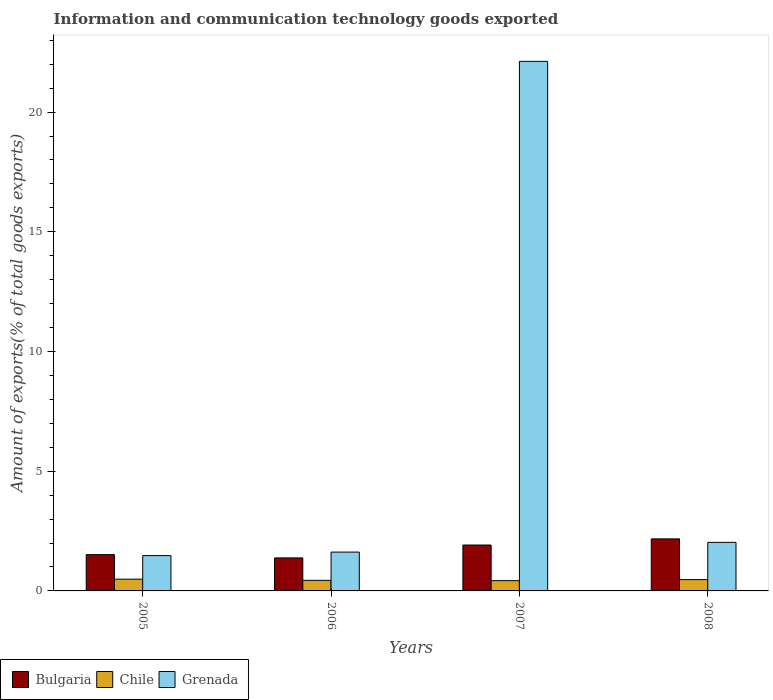How many different coloured bars are there?
Make the answer very short. 3. How many groups of bars are there?
Provide a succinct answer. 4. Are the number of bars per tick equal to the number of legend labels?
Your answer should be very brief. Yes. Are the number of bars on each tick of the X-axis equal?
Ensure brevity in your answer.  Yes. How many bars are there on the 1st tick from the right?
Ensure brevity in your answer.  3. What is the amount of goods exported in Chile in 2007?
Keep it short and to the point. 0.43. Across all years, what is the maximum amount of goods exported in Chile?
Provide a short and direct response. 0.49. Across all years, what is the minimum amount of goods exported in Chile?
Offer a very short reply. 0.43. What is the total amount of goods exported in Chile in the graph?
Provide a short and direct response. 1.84. What is the difference between the amount of goods exported in Chile in 2006 and that in 2007?
Keep it short and to the point. 0.01. What is the difference between the amount of goods exported in Chile in 2008 and the amount of goods exported in Grenada in 2005?
Keep it short and to the point. -1. What is the average amount of goods exported in Grenada per year?
Your response must be concise. 6.81. In the year 2006, what is the difference between the amount of goods exported in Grenada and amount of goods exported in Chile?
Make the answer very short. 1.18. In how many years, is the amount of goods exported in Chile greater than 2 %?
Offer a very short reply. 0. What is the ratio of the amount of goods exported in Bulgaria in 2006 to that in 2008?
Your response must be concise. 0.63. Is the amount of goods exported in Chile in 2005 less than that in 2007?
Your answer should be very brief. No. Is the difference between the amount of goods exported in Grenada in 2005 and 2007 greater than the difference between the amount of goods exported in Chile in 2005 and 2007?
Offer a very short reply. No. What is the difference between the highest and the second highest amount of goods exported in Grenada?
Offer a terse response. 20.09. What is the difference between the highest and the lowest amount of goods exported in Grenada?
Ensure brevity in your answer.  20.65. What does the 3rd bar from the left in 2007 represents?
Give a very brief answer. Grenada. Is it the case that in every year, the sum of the amount of goods exported in Grenada and amount of goods exported in Chile is greater than the amount of goods exported in Bulgaria?
Give a very brief answer. Yes. How many bars are there?
Your answer should be very brief. 12. How many years are there in the graph?
Ensure brevity in your answer.  4. What is the difference between two consecutive major ticks on the Y-axis?
Your answer should be very brief. 5. Does the graph contain any zero values?
Provide a succinct answer. No. Does the graph contain grids?
Keep it short and to the point. No. What is the title of the graph?
Your answer should be very brief. Information and communication technology goods exported. What is the label or title of the X-axis?
Make the answer very short. Years. What is the label or title of the Y-axis?
Provide a succinct answer. Amount of exports(% of total goods exports). What is the Amount of exports(% of total goods exports) in Bulgaria in 2005?
Your answer should be compact. 1.52. What is the Amount of exports(% of total goods exports) of Chile in 2005?
Offer a very short reply. 0.49. What is the Amount of exports(% of total goods exports) in Grenada in 2005?
Make the answer very short. 1.48. What is the Amount of exports(% of total goods exports) in Bulgaria in 2006?
Your answer should be very brief. 1.38. What is the Amount of exports(% of total goods exports) in Chile in 2006?
Your answer should be compact. 0.44. What is the Amount of exports(% of total goods exports) of Grenada in 2006?
Provide a succinct answer. 1.62. What is the Amount of exports(% of total goods exports) of Bulgaria in 2007?
Offer a very short reply. 1.92. What is the Amount of exports(% of total goods exports) in Chile in 2007?
Provide a succinct answer. 0.43. What is the Amount of exports(% of total goods exports) in Grenada in 2007?
Your answer should be very brief. 22.12. What is the Amount of exports(% of total goods exports) of Bulgaria in 2008?
Ensure brevity in your answer.  2.17. What is the Amount of exports(% of total goods exports) of Chile in 2008?
Your answer should be very brief. 0.47. What is the Amount of exports(% of total goods exports) in Grenada in 2008?
Ensure brevity in your answer.  2.03. Across all years, what is the maximum Amount of exports(% of total goods exports) in Bulgaria?
Offer a terse response. 2.17. Across all years, what is the maximum Amount of exports(% of total goods exports) of Chile?
Offer a very short reply. 0.49. Across all years, what is the maximum Amount of exports(% of total goods exports) of Grenada?
Give a very brief answer. 22.12. Across all years, what is the minimum Amount of exports(% of total goods exports) of Bulgaria?
Your response must be concise. 1.38. Across all years, what is the minimum Amount of exports(% of total goods exports) of Chile?
Your answer should be compact. 0.43. Across all years, what is the minimum Amount of exports(% of total goods exports) of Grenada?
Your response must be concise. 1.48. What is the total Amount of exports(% of total goods exports) of Bulgaria in the graph?
Offer a terse response. 6.99. What is the total Amount of exports(% of total goods exports) of Chile in the graph?
Provide a succinct answer. 1.84. What is the total Amount of exports(% of total goods exports) of Grenada in the graph?
Offer a terse response. 27.25. What is the difference between the Amount of exports(% of total goods exports) of Bulgaria in 2005 and that in 2006?
Provide a succinct answer. 0.14. What is the difference between the Amount of exports(% of total goods exports) in Chile in 2005 and that in 2006?
Make the answer very short. 0.05. What is the difference between the Amount of exports(% of total goods exports) in Grenada in 2005 and that in 2006?
Give a very brief answer. -0.15. What is the difference between the Amount of exports(% of total goods exports) of Bulgaria in 2005 and that in 2007?
Give a very brief answer. -0.4. What is the difference between the Amount of exports(% of total goods exports) of Chile in 2005 and that in 2007?
Your response must be concise. 0.06. What is the difference between the Amount of exports(% of total goods exports) of Grenada in 2005 and that in 2007?
Your response must be concise. -20.65. What is the difference between the Amount of exports(% of total goods exports) in Bulgaria in 2005 and that in 2008?
Your answer should be compact. -0.66. What is the difference between the Amount of exports(% of total goods exports) in Chile in 2005 and that in 2008?
Make the answer very short. 0.02. What is the difference between the Amount of exports(% of total goods exports) of Grenada in 2005 and that in 2008?
Keep it short and to the point. -0.55. What is the difference between the Amount of exports(% of total goods exports) of Bulgaria in 2006 and that in 2007?
Give a very brief answer. -0.54. What is the difference between the Amount of exports(% of total goods exports) of Chile in 2006 and that in 2007?
Keep it short and to the point. 0.01. What is the difference between the Amount of exports(% of total goods exports) in Grenada in 2006 and that in 2007?
Give a very brief answer. -20.5. What is the difference between the Amount of exports(% of total goods exports) of Bulgaria in 2006 and that in 2008?
Make the answer very short. -0.8. What is the difference between the Amount of exports(% of total goods exports) in Chile in 2006 and that in 2008?
Provide a short and direct response. -0.03. What is the difference between the Amount of exports(% of total goods exports) in Grenada in 2006 and that in 2008?
Offer a terse response. -0.41. What is the difference between the Amount of exports(% of total goods exports) in Bulgaria in 2007 and that in 2008?
Offer a very short reply. -0.26. What is the difference between the Amount of exports(% of total goods exports) in Chile in 2007 and that in 2008?
Your answer should be compact. -0.05. What is the difference between the Amount of exports(% of total goods exports) of Grenada in 2007 and that in 2008?
Make the answer very short. 20.09. What is the difference between the Amount of exports(% of total goods exports) in Bulgaria in 2005 and the Amount of exports(% of total goods exports) in Chile in 2006?
Ensure brevity in your answer.  1.07. What is the difference between the Amount of exports(% of total goods exports) of Bulgaria in 2005 and the Amount of exports(% of total goods exports) of Grenada in 2006?
Offer a terse response. -0.11. What is the difference between the Amount of exports(% of total goods exports) in Chile in 2005 and the Amount of exports(% of total goods exports) in Grenada in 2006?
Offer a very short reply. -1.13. What is the difference between the Amount of exports(% of total goods exports) of Bulgaria in 2005 and the Amount of exports(% of total goods exports) of Chile in 2007?
Give a very brief answer. 1.09. What is the difference between the Amount of exports(% of total goods exports) in Bulgaria in 2005 and the Amount of exports(% of total goods exports) in Grenada in 2007?
Your response must be concise. -20.6. What is the difference between the Amount of exports(% of total goods exports) of Chile in 2005 and the Amount of exports(% of total goods exports) of Grenada in 2007?
Your answer should be compact. -21.63. What is the difference between the Amount of exports(% of total goods exports) of Bulgaria in 2005 and the Amount of exports(% of total goods exports) of Chile in 2008?
Your response must be concise. 1.04. What is the difference between the Amount of exports(% of total goods exports) of Bulgaria in 2005 and the Amount of exports(% of total goods exports) of Grenada in 2008?
Offer a very short reply. -0.51. What is the difference between the Amount of exports(% of total goods exports) of Chile in 2005 and the Amount of exports(% of total goods exports) of Grenada in 2008?
Make the answer very short. -1.54. What is the difference between the Amount of exports(% of total goods exports) of Bulgaria in 2006 and the Amount of exports(% of total goods exports) of Chile in 2007?
Ensure brevity in your answer.  0.95. What is the difference between the Amount of exports(% of total goods exports) of Bulgaria in 2006 and the Amount of exports(% of total goods exports) of Grenada in 2007?
Provide a short and direct response. -20.74. What is the difference between the Amount of exports(% of total goods exports) of Chile in 2006 and the Amount of exports(% of total goods exports) of Grenada in 2007?
Your response must be concise. -21.68. What is the difference between the Amount of exports(% of total goods exports) of Bulgaria in 2006 and the Amount of exports(% of total goods exports) of Chile in 2008?
Offer a very short reply. 0.91. What is the difference between the Amount of exports(% of total goods exports) in Bulgaria in 2006 and the Amount of exports(% of total goods exports) in Grenada in 2008?
Your response must be concise. -0.65. What is the difference between the Amount of exports(% of total goods exports) in Chile in 2006 and the Amount of exports(% of total goods exports) in Grenada in 2008?
Keep it short and to the point. -1.59. What is the difference between the Amount of exports(% of total goods exports) in Bulgaria in 2007 and the Amount of exports(% of total goods exports) in Chile in 2008?
Give a very brief answer. 1.44. What is the difference between the Amount of exports(% of total goods exports) of Bulgaria in 2007 and the Amount of exports(% of total goods exports) of Grenada in 2008?
Give a very brief answer. -0.11. What is the difference between the Amount of exports(% of total goods exports) of Chile in 2007 and the Amount of exports(% of total goods exports) of Grenada in 2008?
Provide a succinct answer. -1.6. What is the average Amount of exports(% of total goods exports) in Bulgaria per year?
Keep it short and to the point. 1.75. What is the average Amount of exports(% of total goods exports) of Chile per year?
Offer a terse response. 0.46. What is the average Amount of exports(% of total goods exports) of Grenada per year?
Make the answer very short. 6.81. In the year 2005, what is the difference between the Amount of exports(% of total goods exports) of Bulgaria and Amount of exports(% of total goods exports) of Chile?
Offer a terse response. 1.02. In the year 2005, what is the difference between the Amount of exports(% of total goods exports) of Bulgaria and Amount of exports(% of total goods exports) of Grenada?
Keep it short and to the point. 0.04. In the year 2005, what is the difference between the Amount of exports(% of total goods exports) in Chile and Amount of exports(% of total goods exports) in Grenada?
Keep it short and to the point. -0.98. In the year 2006, what is the difference between the Amount of exports(% of total goods exports) in Bulgaria and Amount of exports(% of total goods exports) in Chile?
Your answer should be compact. 0.94. In the year 2006, what is the difference between the Amount of exports(% of total goods exports) of Bulgaria and Amount of exports(% of total goods exports) of Grenada?
Offer a terse response. -0.24. In the year 2006, what is the difference between the Amount of exports(% of total goods exports) of Chile and Amount of exports(% of total goods exports) of Grenada?
Offer a very short reply. -1.18. In the year 2007, what is the difference between the Amount of exports(% of total goods exports) of Bulgaria and Amount of exports(% of total goods exports) of Chile?
Keep it short and to the point. 1.49. In the year 2007, what is the difference between the Amount of exports(% of total goods exports) in Bulgaria and Amount of exports(% of total goods exports) in Grenada?
Give a very brief answer. -20.2. In the year 2007, what is the difference between the Amount of exports(% of total goods exports) in Chile and Amount of exports(% of total goods exports) in Grenada?
Give a very brief answer. -21.69. In the year 2008, what is the difference between the Amount of exports(% of total goods exports) of Bulgaria and Amount of exports(% of total goods exports) of Chile?
Offer a terse response. 1.7. In the year 2008, what is the difference between the Amount of exports(% of total goods exports) in Bulgaria and Amount of exports(% of total goods exports) in Grenada?
Provide a short and direct response. 0.15. In the year 2008, what is the difference between the Amount of exports(% of total goods exports) in Chile and Amount of exports(% of total goods exports) in Grenada?
Offer a very short reply. -1.56. What is the ratio of the Amount of exports(% of total goods exports) of Bulgaria in 2005 to that in 2006?
Ensure brevity in your answer.  1.1. What is the ratio of the Amount of exports(% of total goods exports) in Chile in 2005 to that in 2006?
Provide a succinct answer. 1.11. What is the ratio of the Amount of exports(% of total goods exports) of Grenada in 2005 to that in 2006?
Offer a terse response. 0.91. What is the ratio of the Amount of exports(% of total goods exports) in Bulgaria in 2005 to that in 2007?
Your answer should be compact. 0.79. What is the ratio of the Amount of exports(% of total goods exports) of Chile in 2005 to that in 2007?
Offer a terse response. 1.15. What is the ratio of the Amount of exports(% of total goods exports) of Grenada in 2005 to that in 2007?
Give a very brief answer. 0.07. What is the ratio of the Amount of exports(% of total goods exports) of Bulgaria in 2005 to that in 2008?
Offer a very short reply. 0.7. What is the ratio of the Amount of exports(% of total goods exports) in Chile in 2005 to that in 2008?
Your answer should be compact. 1.04. What is the ratio of the Amount of exports(% of total goods exports) in Grenada in 2005 to that in 2008?
Provide a short and direct response. 0.73. What is the ratio of the Amount of exports(% of total goods exports) in Bulgaria in 2006 to that in 2007?
Make the answer very short. 0.72. What is the ratio of the Amount of exports(% of total goods exports) of Chile in 2006 to that in 2007?
Offer a terse response. 1.03. What is the ratio of the Amount of exports(% of total goods exports) in Grenada in 2006 to that in 2007?
Provide a short and direct response. 0.07. What is the ratio of the Amount of exports(% of total goods exports) in Bulgaria in 2006 to that in 2008?
Make the answer very short. 0.63. What is the ratio of the Amount of exports(% of total goods exports) of Chile in 2006 to that in 2008?
Provide a short and direct response. 0.93. What is the ratio of the Amount of exports(% of total goods exports) in Grenada in 2006 to that in 2008?
Make the answer very short. 0.8. What is the ratio of the Amount of exports(% of total goods exports) of Bulgaria in 2007 to that in 2008?
Make the answer very short. 0.88. What is the ratio of the Amount of exports(% of total goods exports) in Chile in 2007 to that in 2008?
Provide a short and direct response. 0.9. What is the ratio of the Amount of exports(% of total goods exports) of Grenada in 2007 to that in 2008?
Your answer should be compact. 10.9. What is the difference between the highest and the second highest Amount of exports(% of total goods exports) of Bulgaria?
Your answer should be compact. 0.26. What is the difference between the highest and the second highest Amount of exports(% of total goods exports) in Chile?
Make the answer very short. 0.02. What is the difference between the highest and the second highest Amount of exports(% of total goods exports) of Grenada?
Make the answer very short. 20.09. What is the difference between the highest and the lowest Amount of exports(% of total goods exports) of Bulgaria?
Offer a very short reply. 0.8. What is the difference between the highest and the lowest Amount of exports(% of total goods exports) of Chile?
Provide a short and direct response. 0.06. What is the difference between the highest and the lowest Amount of exports(% of total goods exports) of Grenada?
Your answer should be compact. 20.65. 